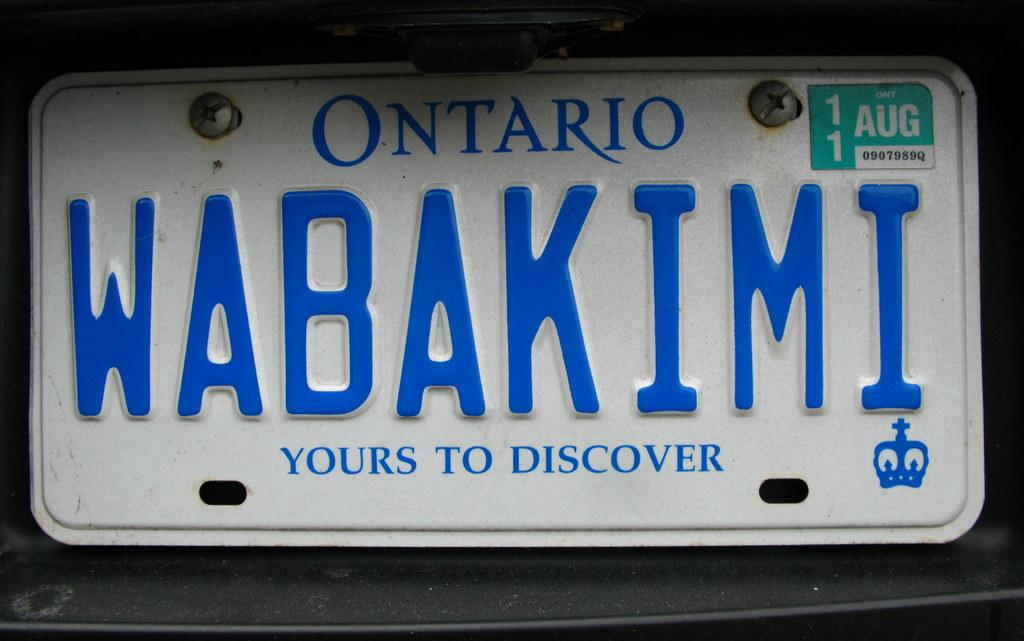What is the main subject of the image? The main subject of the image is a registration plate of a vehicle. Are there any additional features on the registration plate? Yes, there are screws on the registration plate. Is there any other object or sticker on the registration plate? Yes, there is a sticker on the registration plate. What can be seen behind the registration plate? There is a black object behind the registration plate. Can you tell me how many waves are visible behind the registration plate? There are no waves visible behind the registration plate; it is a black object. What type of cabbage is growing next to the registration plate? There is no cabbage present in the image; it is a registration plate with a black object behind it. 